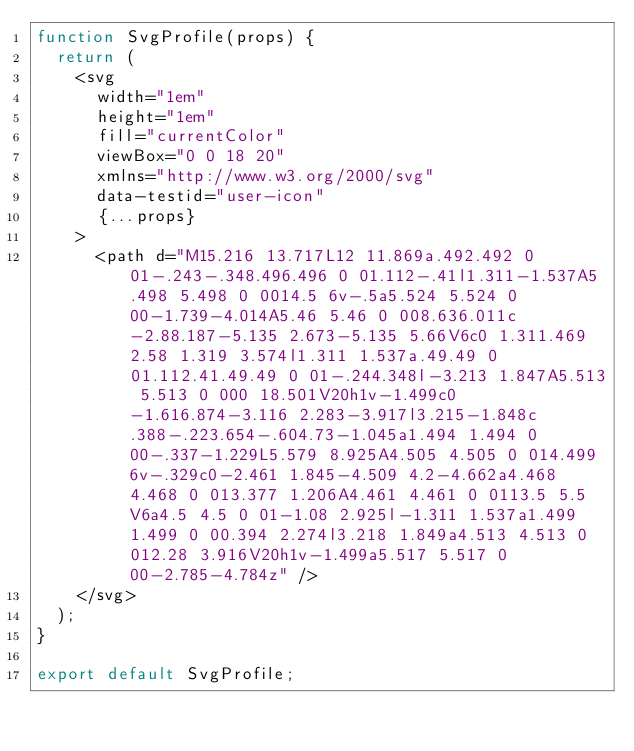<code> <loc_0><loc_0><loc_500><loc_500><_JavaScript_>function SvgProfile(props) {
  return (
    <svg
      width="1em"
      height="1em"
      fill="currentColor"
      viewBox="0 0 18 20"
      xmlns="http://www.w3.org/2000/svg"
      data-testid="user-icon"
      {...props}
    >
      <path d="M15.216 13.717L12 11.869a.492.492 0 01-.243-.348.496.496 0 01.112-.41l1.311-1.537A5.498 5.498 0 0014.5 6v-.5a5.524 5.524 0 00-1.739-4.014A5.46 5.46 0 008.636.011c-2.88.187-5.135 2.673-5.135 5.66V6c0 1.311.469 2.58 1.319 3.574l1.311 1.537a.49.49 0 01.112.41.49.49 0 01-.244.348l-3.213 1.847A5.513 5.513 0 000 18.501V20h1v-1.499c0-1.616.874-3.116 2.283-3.917l3.215-1.848c.388-.223.654-.604.73-1.045a1.494 1.494 0 00-.337-1.229L5.579 8.925A4.505 4.505 0 014.499 6v-.329c0-2.461 1.845-4.509 4.2-4.662a4.468 4.468 0 013.377 1.206A4.461 4.461 0 0113.5 5.5V6a4.5 4.5 0 01-1.08 2.925l-1.311 1.537a1.499 1.499 0 00.394 2.274l3.218 1.849a4.513 4.513 0 012.28 3.916V20h1v-1.499a5.517 5.517 0 00-2.785-4.784z" />
    </svg>
  );
}

export default SvgProfile;
</code> 